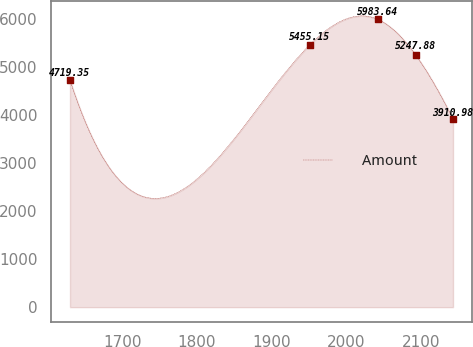Convert chart to OTSL. <chart><loc_0><loc_0><loc_500><loc_500><line_chart><ecel><fcel>Amount<nl><fcel>1630.04<fcel>4719.35<nl><fcel>1950.86<fcel>5455.15<nl><fcel>2042.1<fcel>5983.64<nl><fcel>2092.3<fcel>5247.88<nl><fcel>2142.5<fcel>3910.98<nl></chart> 